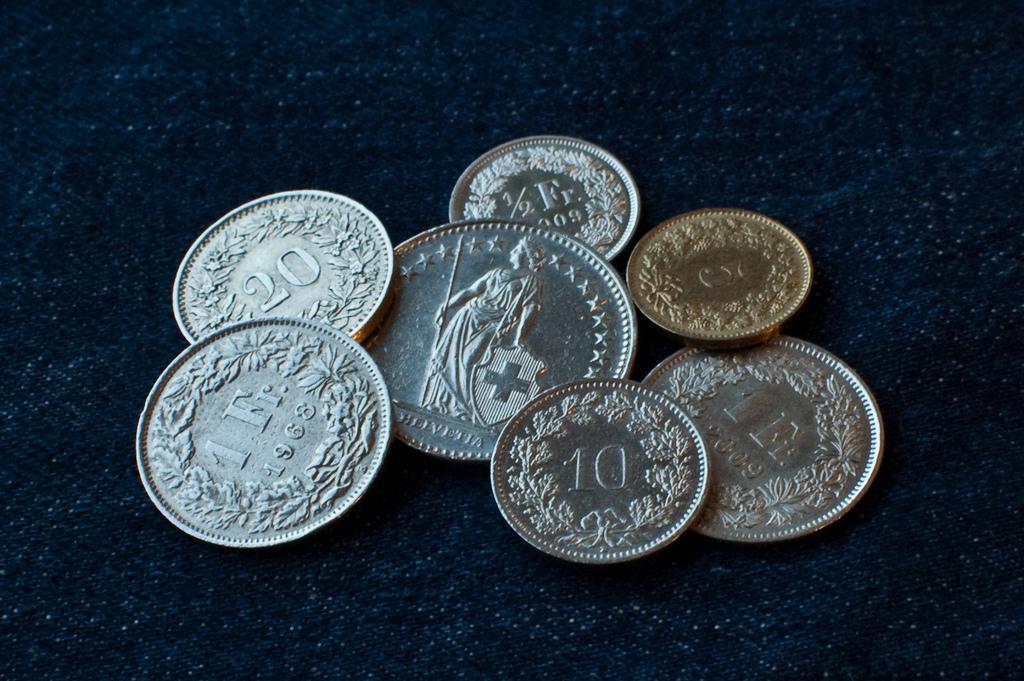What number is seen on one of the coins?
Your answer should be very brief. 10. 